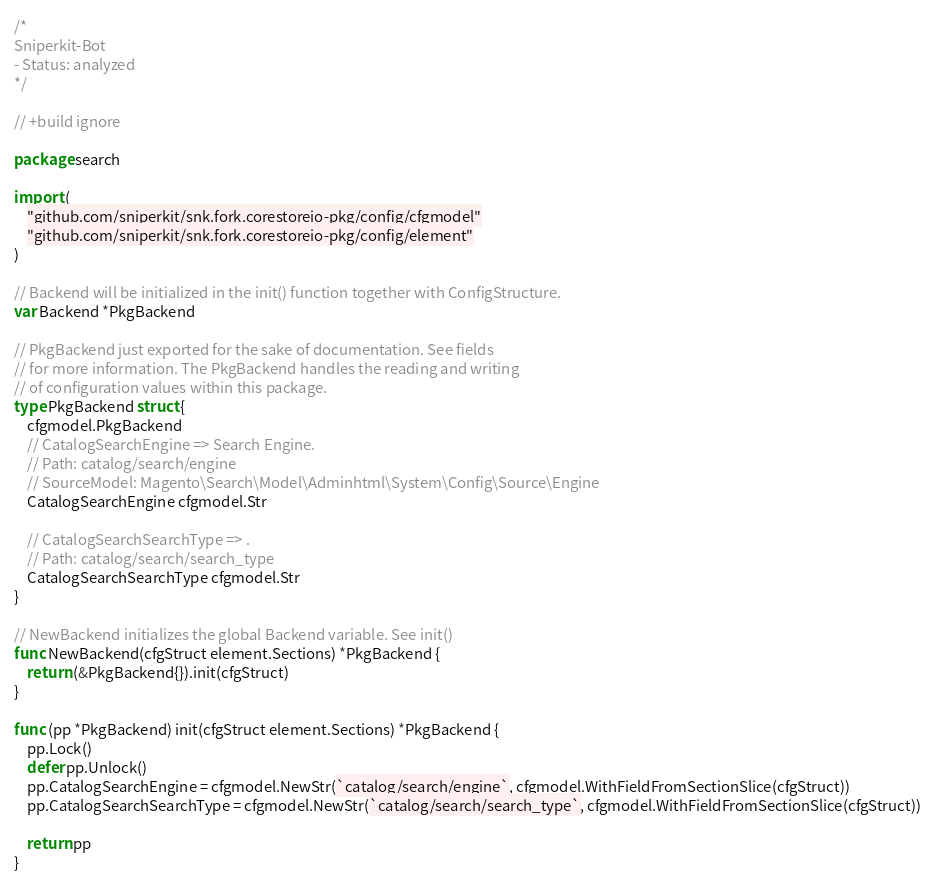<code> <loc_0><loc_0><loc_500><loc_500><_Go_>/*
Sniperkit-Bot
- Status: analyzed
*/

// +build ignore

package search

import (
	"github.com/sniperkit/snk.fork.corestoreio-pkg/config/cfgmodel"
	"github.com/sniperkit/snk.fork.corestoreio-pkg/config/element"
)

// Backend will be initialized in the init() function together with ConfigStructure.
var Backend *PkgBackend

// PkgBackend just exported for the sake of documentation. See fields
// for more information. The PkgBackend handles the reading and writing
// of configuration values within this package.
type PkgBackend struct {
	cfgmodel.PkgBackend
	// CatalogSearchEngine => Search Engine.
	// Path: catalog/search/engine
	// SourceModel: Magento\Search\Model\Adminhtml\System\Config\Source\Engine
	CatalogSearchEngine cfgmodel.Str

	// CatalogSearchSearchType => .
	// Path: catalog/search/search_type
	CatalogSearchSearchType cfgmodel.Str
}

// NewBackend initializes the global Backend variable. See init()
func NewBackend(cfgStruct element.Sections) *PkgBackend {
	return (&PkgBackend{}).init(cfgStruct)
}

func (pp *PkgBackend) init(cfgStruct element.Sections) *PkgBackend {
	pp.Lock()
	defer pp.Unlock()
	pp.CatalogSearchEngine = cfgmodel.NewStr(`catalog/search/engine`, cfgmodel.WithFieldFromSectionSlice(cfgStruct))
	pp.CatalogSearchSearchType = cfgmodel.NewStr(`catalog/search/search_type`, cfgmodel.WithFieldFromSectionSlice(cfgStruct))

	return pp
}
</code> 